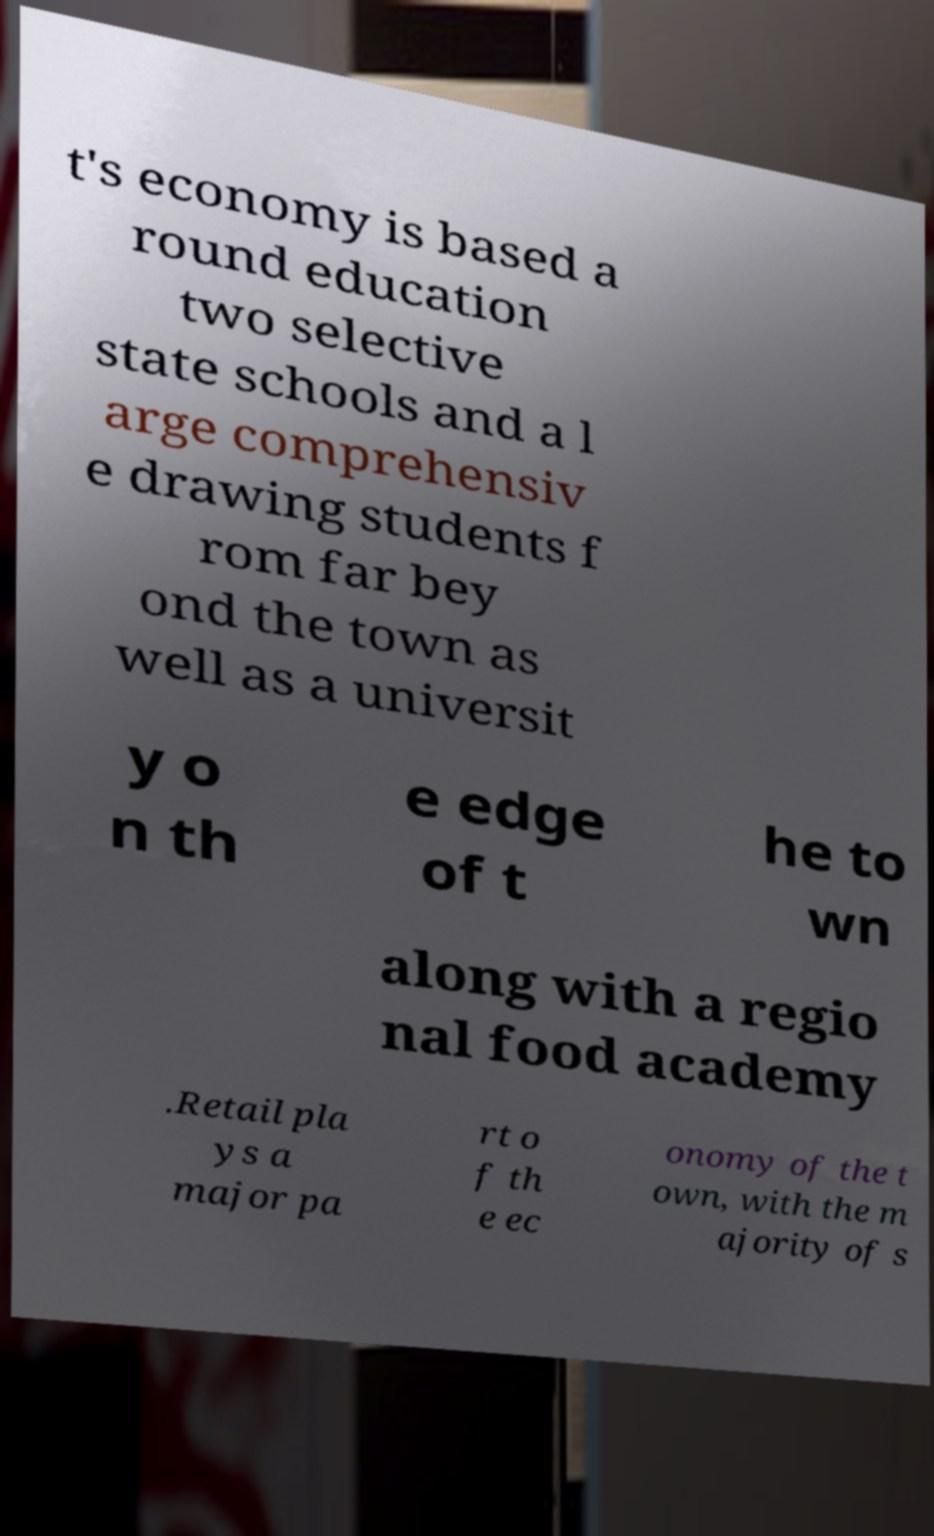Please identify and transcribe the text found in this image. t's economy is based a round education two selective state schools and a l arge comprehensiv e drawing students f rom far bey ond the town as well as a universit y o n th e edge of t he to wn along with a regio nal food academy .Retail pla ys a major pa rt o f th e ec onomy of the t own, with the m ajority of s 